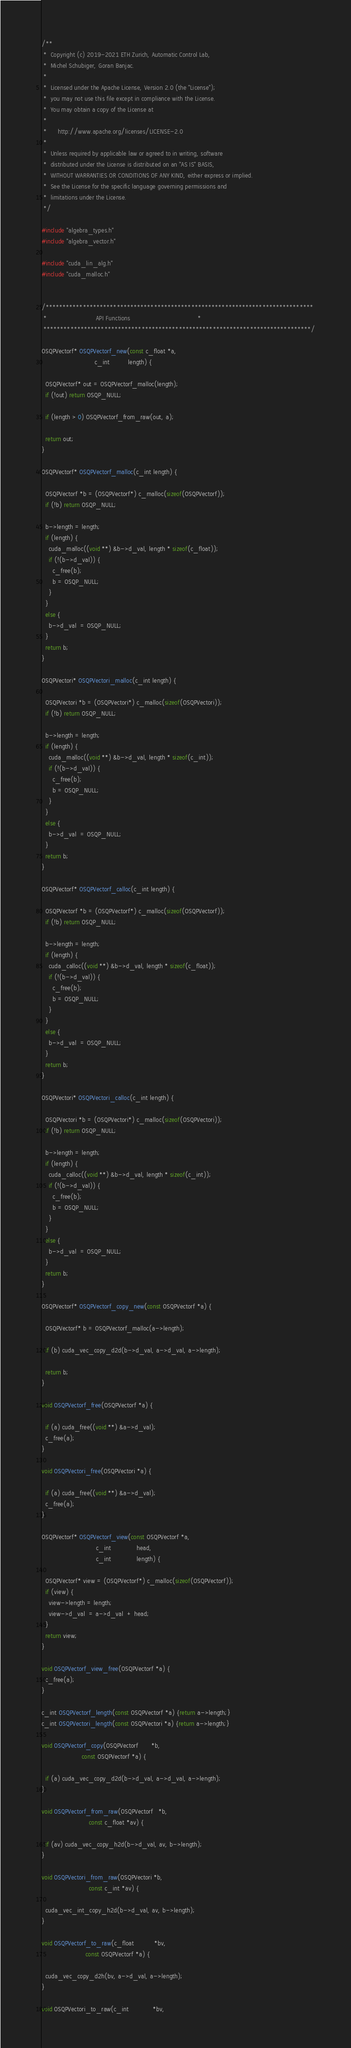<code> <loc_0><loc_0><loc_500><loc_500><_Cuda_>/**
 *  Copyright (c) 2019-2021 ETH Zurich, Automatic Control Lab,
 *  Michel Schubiger, Goran Banjac.
 *
 *  Licensed under the Apache License, Version 2.0 (the "License");
 *  you may not use this file except in compliance with the License.
 *  You may obtain a copy of the License at
 *
 *      http://www.apache.org/licenses/LICENSE-2.0
 *
 *  Unless required by applicable law or agreed to in writing, software
 *  distributed under the License is distributed on an "AS IS" BASIS,
 *  WITHOUT WARRANTIES OR CONDITIONS OF ANY KIND, either express or implied.
 *  See the License for the specific language governing permissions and
 *  limitations under the License.
 */

#include "algebra_types.h"
#include "algebra_vector.h"

#include "cuda_lin_alg.h"
#include "cuda_malloc.h"


/*******************************************************************************
 *                           API Functions                                     *
 *******************************************************************************/

OSQPVectorf* OSQPVectorf_new(const c_float *a,
                             c_int          length) {

  OSQPVectorf* out = OSQPVectorf_malloc(length);
  if (!out) return OSQP_NULL;

  if (length > 0) OSQPVectorf_from_raw(out, a);
  
  return out;
}

OSQPVectorf* OSQPVectorf_malloc(c_int length) {

  OSQPVectorf *b = (OSQPVectorf*) c_malloc(sizeof(OSQPVectorf));
  if (!b) return OSQP_NULL;

  b->length = length;
  if (length) {
    cuda_malloc((void **) &b->d_val, length * sizeof(c_float));
    if (!(b->d_val)) {
      c_free(b);
      b = OSQP_NULL;
    }
  }
  else {
    b->d_val  = OSQP_NULL;
  }
  return b;
}

OSQPVectori* OSQPVectori_malloc(c_int length) {

  OSQPVectori *b = (OSQPVectori*) c_malloc(sizeof(OSQPVectori));
  if (!b) return OSQP_NULL;

  b->length = length;
  if (length) {
    cuda_malloc((void **) &b->d_val, length * sizeof(c_int));
    if (!(b->d_val)) {
      c_free(b);
      b = OSQP_NULL;
    }
  }
  else {
    b->d_val  = OSQP_NULL;
  }
  return b;
}

OSQPVectorf* OSQPVectorf_calloc(c_int length) {

  OSQPVectorf *b = (OSQPVectorf*) c_malloc(sizeof(OSQPVectorf));
  if (!b) return OSQP_NULL;

  b->length = length;
  if (length) {
    cuda_calloc((void **) &b->d_val, length * sizeof(c_float));
    if (!(b->d_val)) {
      c_free(b);
      b = OSQP_NULL;
    }
  }
  else {
    b->d_val  = OSQP_NULL;
  }
  return b;
}

OSQPVectori* OSQPVectori_calloc(c_int length) {

  OSQPVectori *b = (OSQPVectori*) c_malloc(sizeof(OSQPVectori));
  if (!b) return OSQP_NULL;
  
  b->length = length;
  if (length) {
    cuda_calloc((void **) &b->d_val, length * sizeof(c_int));
    if (!(b->d_val)) {
      c_free(b);
      b = OSQP_NULL;
    }
  }
  else {
    b->d_val  = OSQP_NULL;
  }
  return b;
}

OSQPVectorf* OSQPVectorf_copy_new(const OSQPVectorf *a) {

  OSQPVectorf* b = OSQPVectorf_malloc(a->length);

  if (b) cuda_vec_copy_d2d(b->d_val, a->d_val, a->length);

  return b;
}

void OSQPVectorf_free(OSQPVectorf *a) {

  if (a) cuda_free((void **) &a->d_val);
  c_free(a);
}

void OSQPVectori_free(OSQPVectori *a) {

  if (a) cuda_free((void **) &a->d_val);
  c_free(a);
}

OSQPVectorf* OSQPVectorf_view(const OSQPVectorf *a,
                              c_int              head,
                              c_int              length) {

  OSQPVectorf* view = (OSQPVectorf*) c_malloc(sizeof(OSQPVectorf));
  if (view) {
    view->length = length;
    view->d_val  = a->d_val  + head;
  }
  return view;
}

void OSQPVectorf_view_free(OSQPVectorf *a) {
  c_free(a);
}

c_int OSQPVectorf_length(const OSQPVectorf *a) {return a->length;}
c_int OSQPVectori_length(const OSQPVectori *a) {return a->length;}

void OSQPVectorf_copy(OSQPVectorf       *b,
                      const OSQPVectorf *a) {

  if (a) cuda_vec_copy_d2d(b->d_val, a->d_val, a->length);
}

void OSQPVectorf_from_raw(OSQPVectorf   *b,
                          const c_float *av) {

  if (av) cuda_vec_copy_h2d(b->d_val, av, b->length);
}

void OSQPVectori_from_raw(OSQPVectori *b,
                          const c_int *av) {

  cuda_vec_int_copy_h2d(b->d_val, av, b->length);
}

void OSQPVectorf_to_raw(c_float           *bv,
                        const OSQPVectorf *a) {

  cuda_vec_copy_d2h(bv, a->d_val, a->length);
}

void OSQPVectori_to_raw(c_int             *bv,</code> 